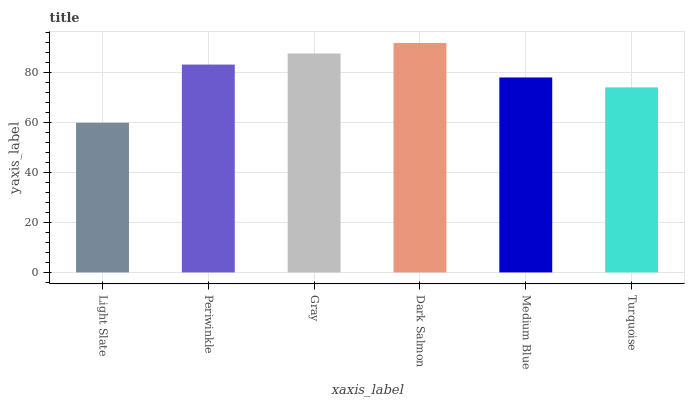Is Light Slate the minimum?
Answer yes or no. Yes. Is Dark Salmon the maximum?
Answer yes or no. Yes. Is Periwinkle the minimum?
Answer yes or no. No. Is Periwinkle the maximum?
Answer yes or no. No. Is Periwinkle greater than Light Slate?
Answer yes or no. Yes. Is Light Slate less than Periwinkle?
Answer yes or no. Yes. Is Light Slate greater than Periwinkle?
Answer yes or no. No. Is Periwinkle less than Light Slate?
Answer yes or no. No. Is Periwinkle the high median?
Answer yes or no. Yes. Is Medium Blue the low median?
Answer yes or no. Yes. Is Gray the high median?
Answer yes or no. No. Is Periwinkle the low median?
Answer yes or no. No. 